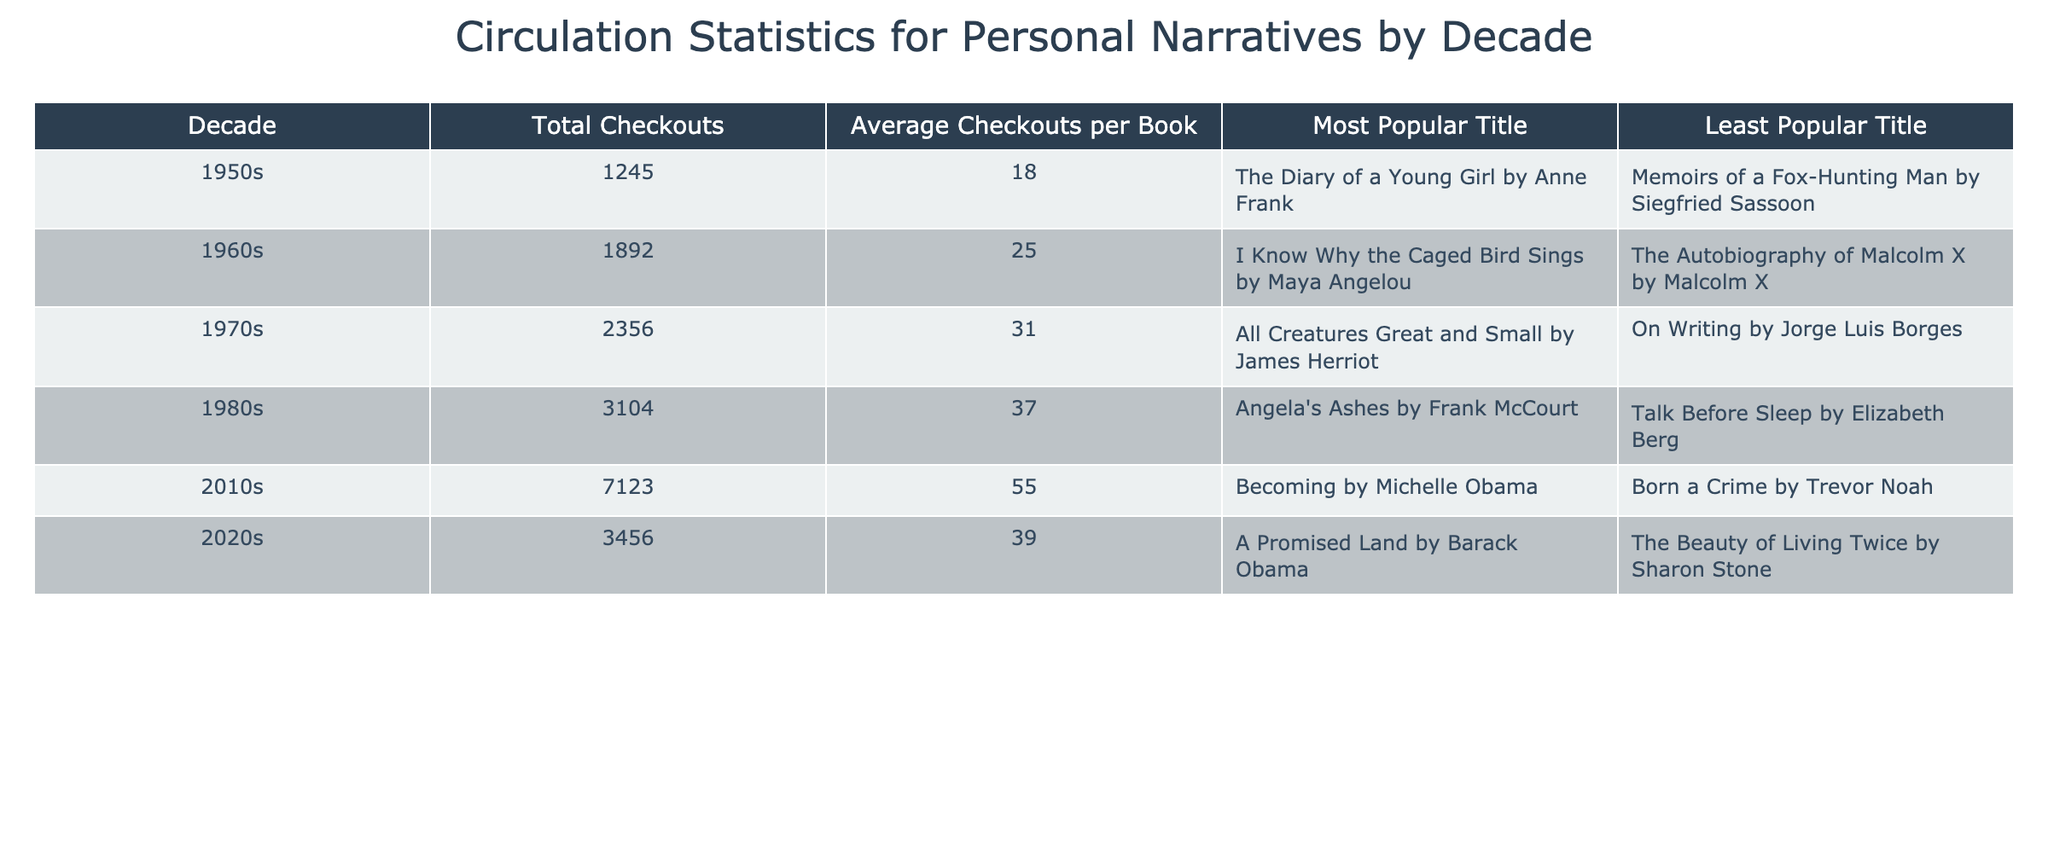What decade had the highest total checkouts? The table shows that the 2010s had the highest total checkouts at 7123.
Answer: 2010s What is the average checkouts per book for the 1980s? The table states that the average checkouts per book for the 1980s is 37.
Answer: 37 Which title had the least number of checkouts in the 1960s? According to the table, "The Autobiography of Malcolm X" had the least number of checkouts in the 1960s.
Answer: The Autobiography of Malcolm X by Malcolm X How many total checkouts were there from the 1970s and 1980s combined? The total checkouts for the 1970s is 2356 and for the 1980s is 3104. Adding these together gives 2356 + 3104 = 5460.
Answer: 5460 Is it true that "Becoming" by Michelle Obama was the most popular title of the 2010s? Yes, the table confirms that "Becoming" by Michelle Obama was indeed the most popular title of the 2010s.
Answer: Yes Which decade has the highest average checkouts per book? The table lists the average checkouts per book for each decade. The 2010s have 55, which is the highest among all decades.
Answer: 2010s What is the difference in total checkouts between the 1950s and the 2020s? The total checkouts for the 1950s is 1245 and for the 2020s is 3456. The difference is calculated as 3456 - 1245 = 2211.
Answer: 2211 Which title is the most popular in the 2020s? According to the table, "A Promised Land" by Barack Obama is the most popular title in the 2020s.
Answer: A Promised Land by Barack Obama What was the average checkouts per book in the 1950s and how does it compare to the 1960s? The average checkouts per book in the 1950s were 18, while in the 1960s it was 25. The 1960s average is higher by 7 (25 - 18 = 7).
Answer: 7 Which decade had the lowest total checkouts? Looking at the total checkouts, the 1950s had the lowest total at 1245.
Answer: 1950s 